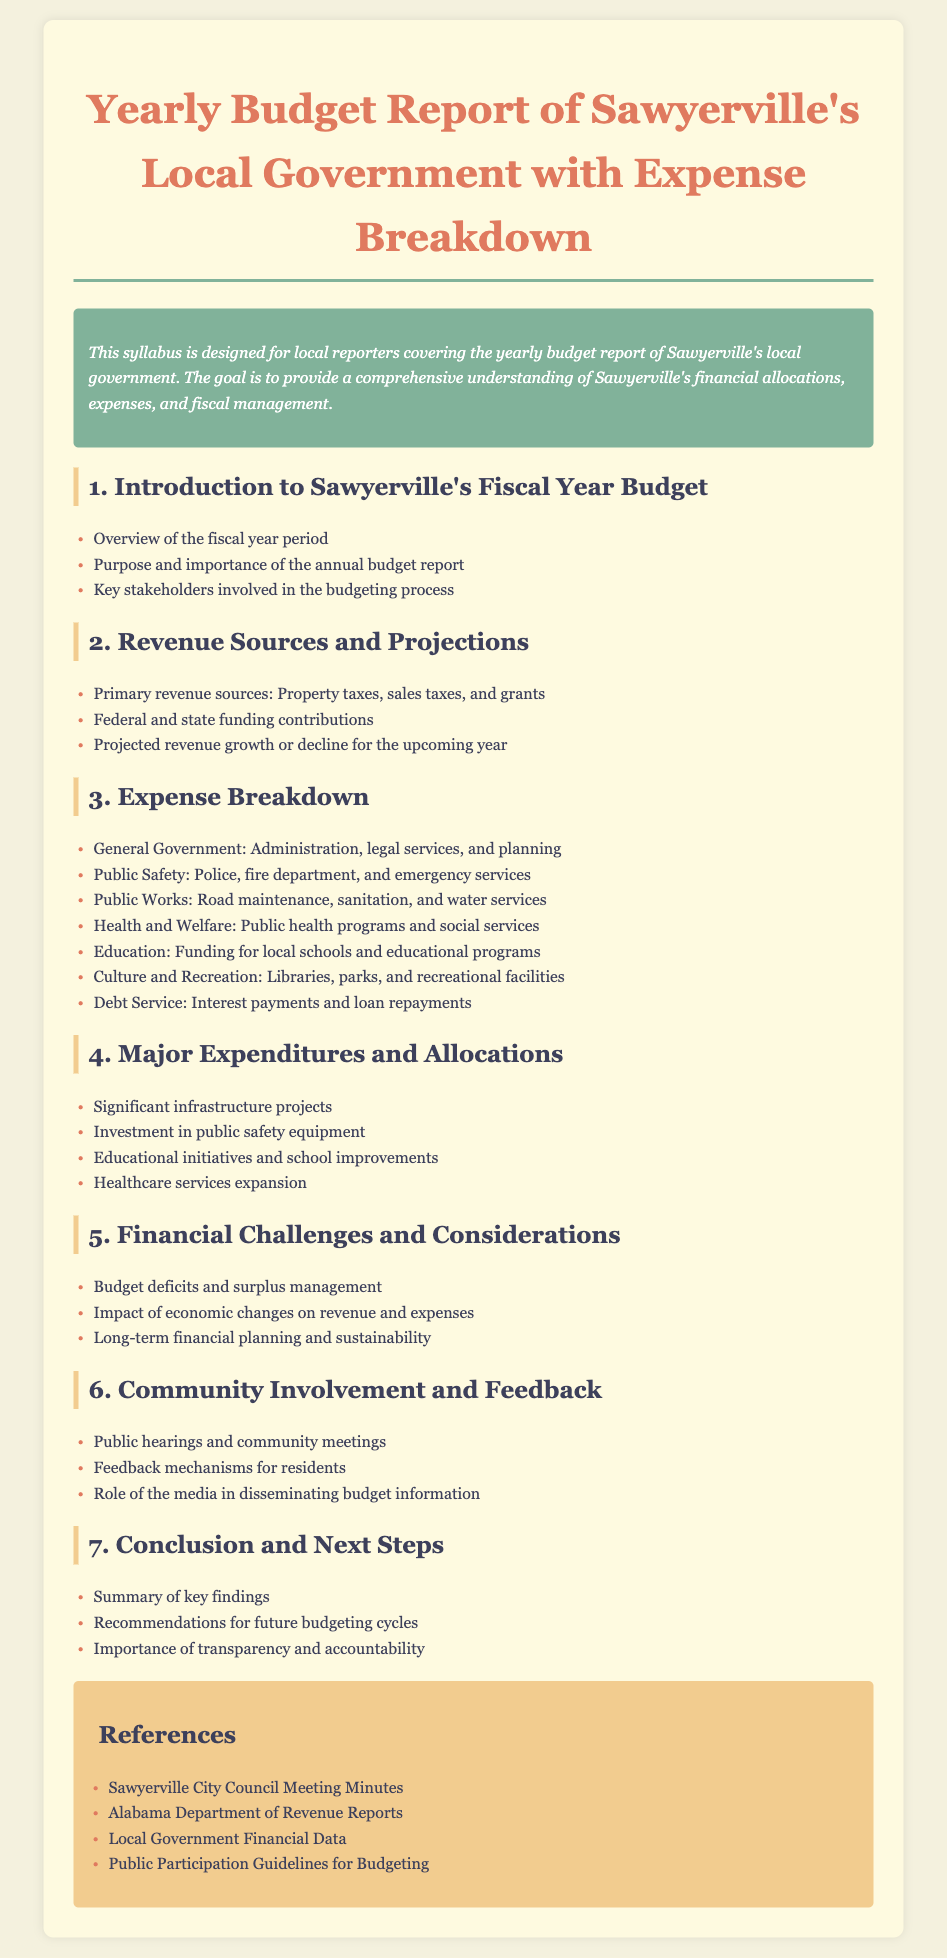What is the purpose of the annual budget report? The purpose of the annual budget report is to provide a comprehensive understanding of Sawyerville's financial allocations, expenses, and fiscal management.
Answer: To provide a comprehensive understanding of financial allocations, expenses, and fiscal management What are the primary revenue sources? The primary revenue sources listed in the document include property taxes, sales taxes, and grants.
Answer: Property taxes, sales taxes, and grants What areas are covered under general government expenses? The document mentions administration, legal services, and planning under general government expenses.
Answer: Administration, legal services, and planning Which department relates to public safety? The public safety department includes the police and fire department and emergency services as noted in the expense breakdown section.
Answer: Police, fire department, and emergency services What is a significant challenge mentioned in the financial section? The document highlights budget deficits and surplus management as a major financial challenge for Sawyerville's local government.
Answer: Budget deficits and surplus management What type of community involvement is mentioned in the syllabus? The syllabus includes public hearings and community meetings as a form of community involvement and feedback regarding the budget.
Answer: Public hearings and community meetings What is the focus of the conclusion section? The focus of the conclusion section includes summarizing key findings and recommendations for future budgeting cycles.
Answer: Summary of key findings and recommendations for future budgeting cycles What is the title of the syllabus? The title of the syllabus clearly states "Yearly Budget Report of Sawyerville's Local Government with Expense Breakdown".
Answer: Yearly Budget Report of Sawyerville's Local Government with Expense Breakdown Which organization’s reports are referenced in the document? The document references reports from the Alabama Department of Revenue.
Answer: Alabama Department of Revenue Reports 